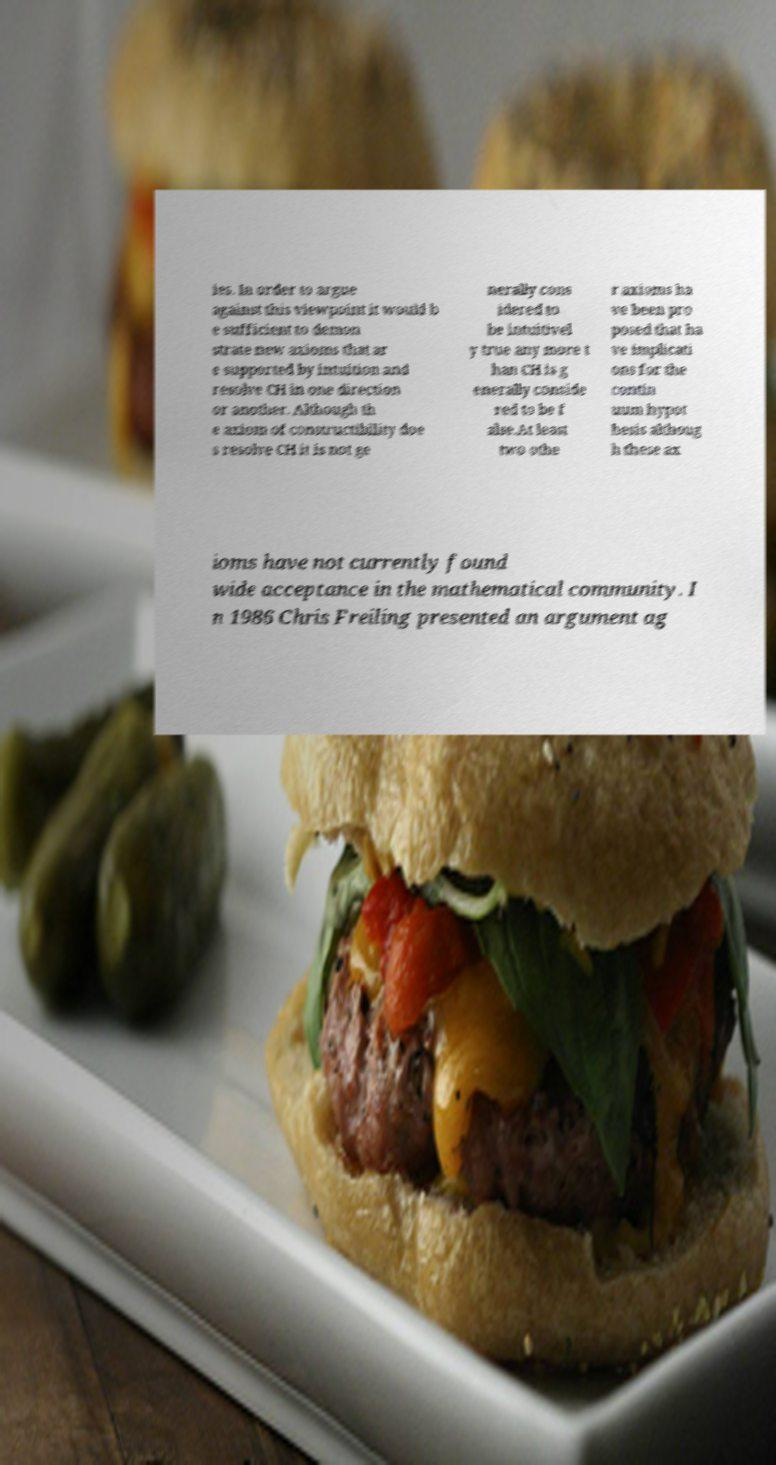What messages or text are displayed in this image? I need them in a readable, typed format. ies. In order to argue against this viewpoint it would b e sufficient to demon strate new axioms that ar e supported by intuition and resolve CH in one direction or another. Although th e axiom of constructibility doe s resolve CH it is not ge nerally cons idered to be intuitivel y true any more t han CH is g enerally conside red to be f alse.At least two othe r axioms ha ve been pro posed that ha ve implicati ons for the contin uum hypot hesis althoug h these ax ioms have not currently found wide acceptance in the mathematical community. I n 1986 Chris Freiling presented an argument ag 